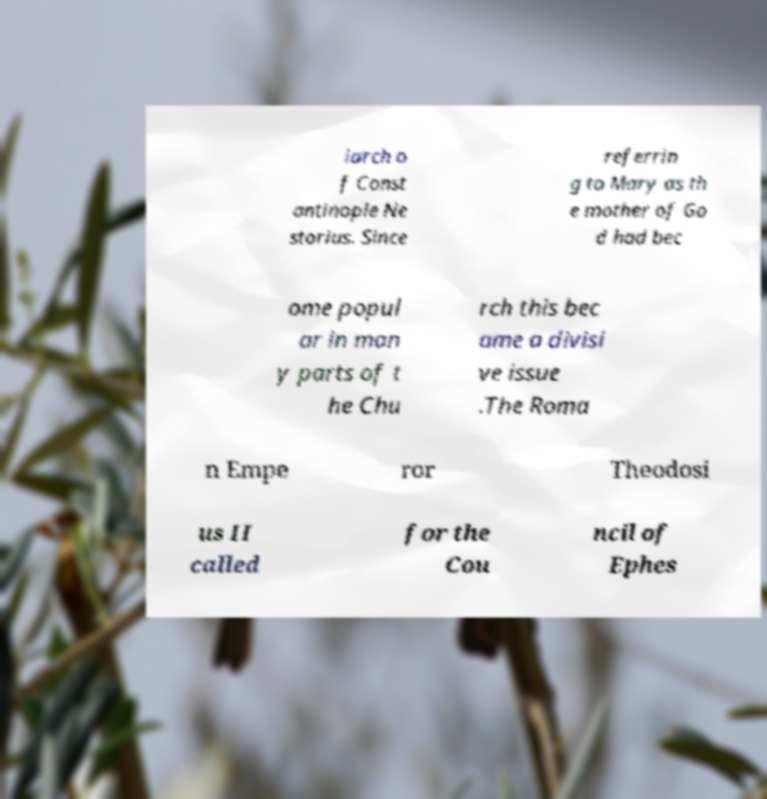Could you assist in decoding the text presented in this image and type it out clearly? iarch o f Const antinople Ne storius. Since referrin g to Mary as th e mother of Go d had bec ome popul ar in man y parts of t he Chu rch this bec ame a divisi ve issue .The Roma n Empe ror Theodosi us II called for the Cou ncil of Ephes 